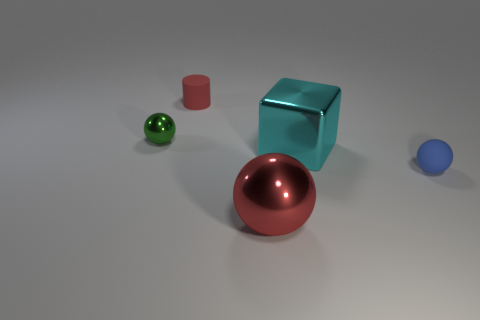What is the color of the big thing that is the same shape as the small green metallic thing?
Provide a succinct answer. Red. Is there anything else that is the same shape as the tiny blue object?
Your answer should be compact. Yes. What is the shape of the big metal thing that is to the left of the cyan shiny cube?
Offer a terse response. Sphere. How many other large metal objects have the same shape as the big cyan thing?
Make the answer very short. 0. Does the small matte object that is behind the large cyan metallic thing have the same color as the big thing that is behind the small matte sphere?
Provide a succinct answer. No. What number of things are big brown objects or tiny red cylinders?
Give a very brief answer. 1. What number of other large red balls are the same material as the red ball?
Offer a terse response. 0. Are there fewer balls than red rubber objects?
Offer a very short reply. No. Is the material of the small object on the right side of the tiny red object the same as the tiny green sphere?
Keep it short and to the point. No. How many blocks are tiny metal objects or big metallic things?
Your answer should be compact. 1. 